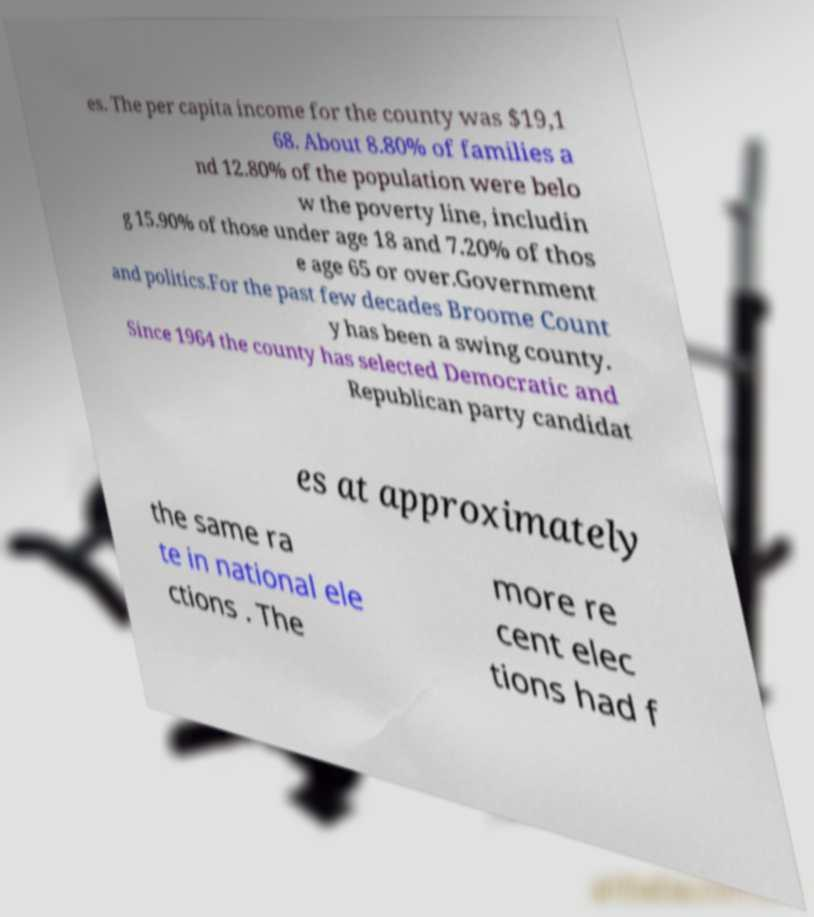Please identify and transcribe the text found in this image. es. The per capita income for the county was $19,1 68. About 8.80% of families a nd 12.80% of the population were belo w the poverty line, includin g 15.90% of those under age 18 and 7.20% of thos e age 65 or over.Government and politics.For the past few decades Broome Count y has been a swing county. Since 1964 the county has selected Democratic and Republican party candidat es at approximately the same ra te in national ele ctions . The more re cent elec tions had f 